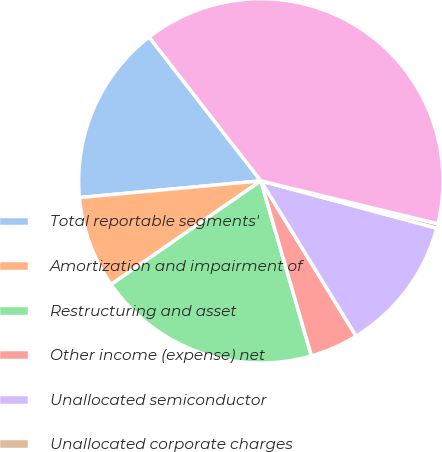<chart> <loc_0><loc_0><loc_500><loc_500><pie_chart><fcel>Total reportable segments'<fcel>Amortization and impairment of<fcel>Restructuring and asset<fcel>Other income (expense) net<fcel>Unallocated semiconductor<fcel>Unallocated corporate charges<fcel>Income (loss) from continuing<nl><fcel>15.95%<fcel>8.17%<fcel>19.84%<fcel>4.28%<fcel>12.06%<fcel>0.4%<fcel>39.29%<nl></chart> 